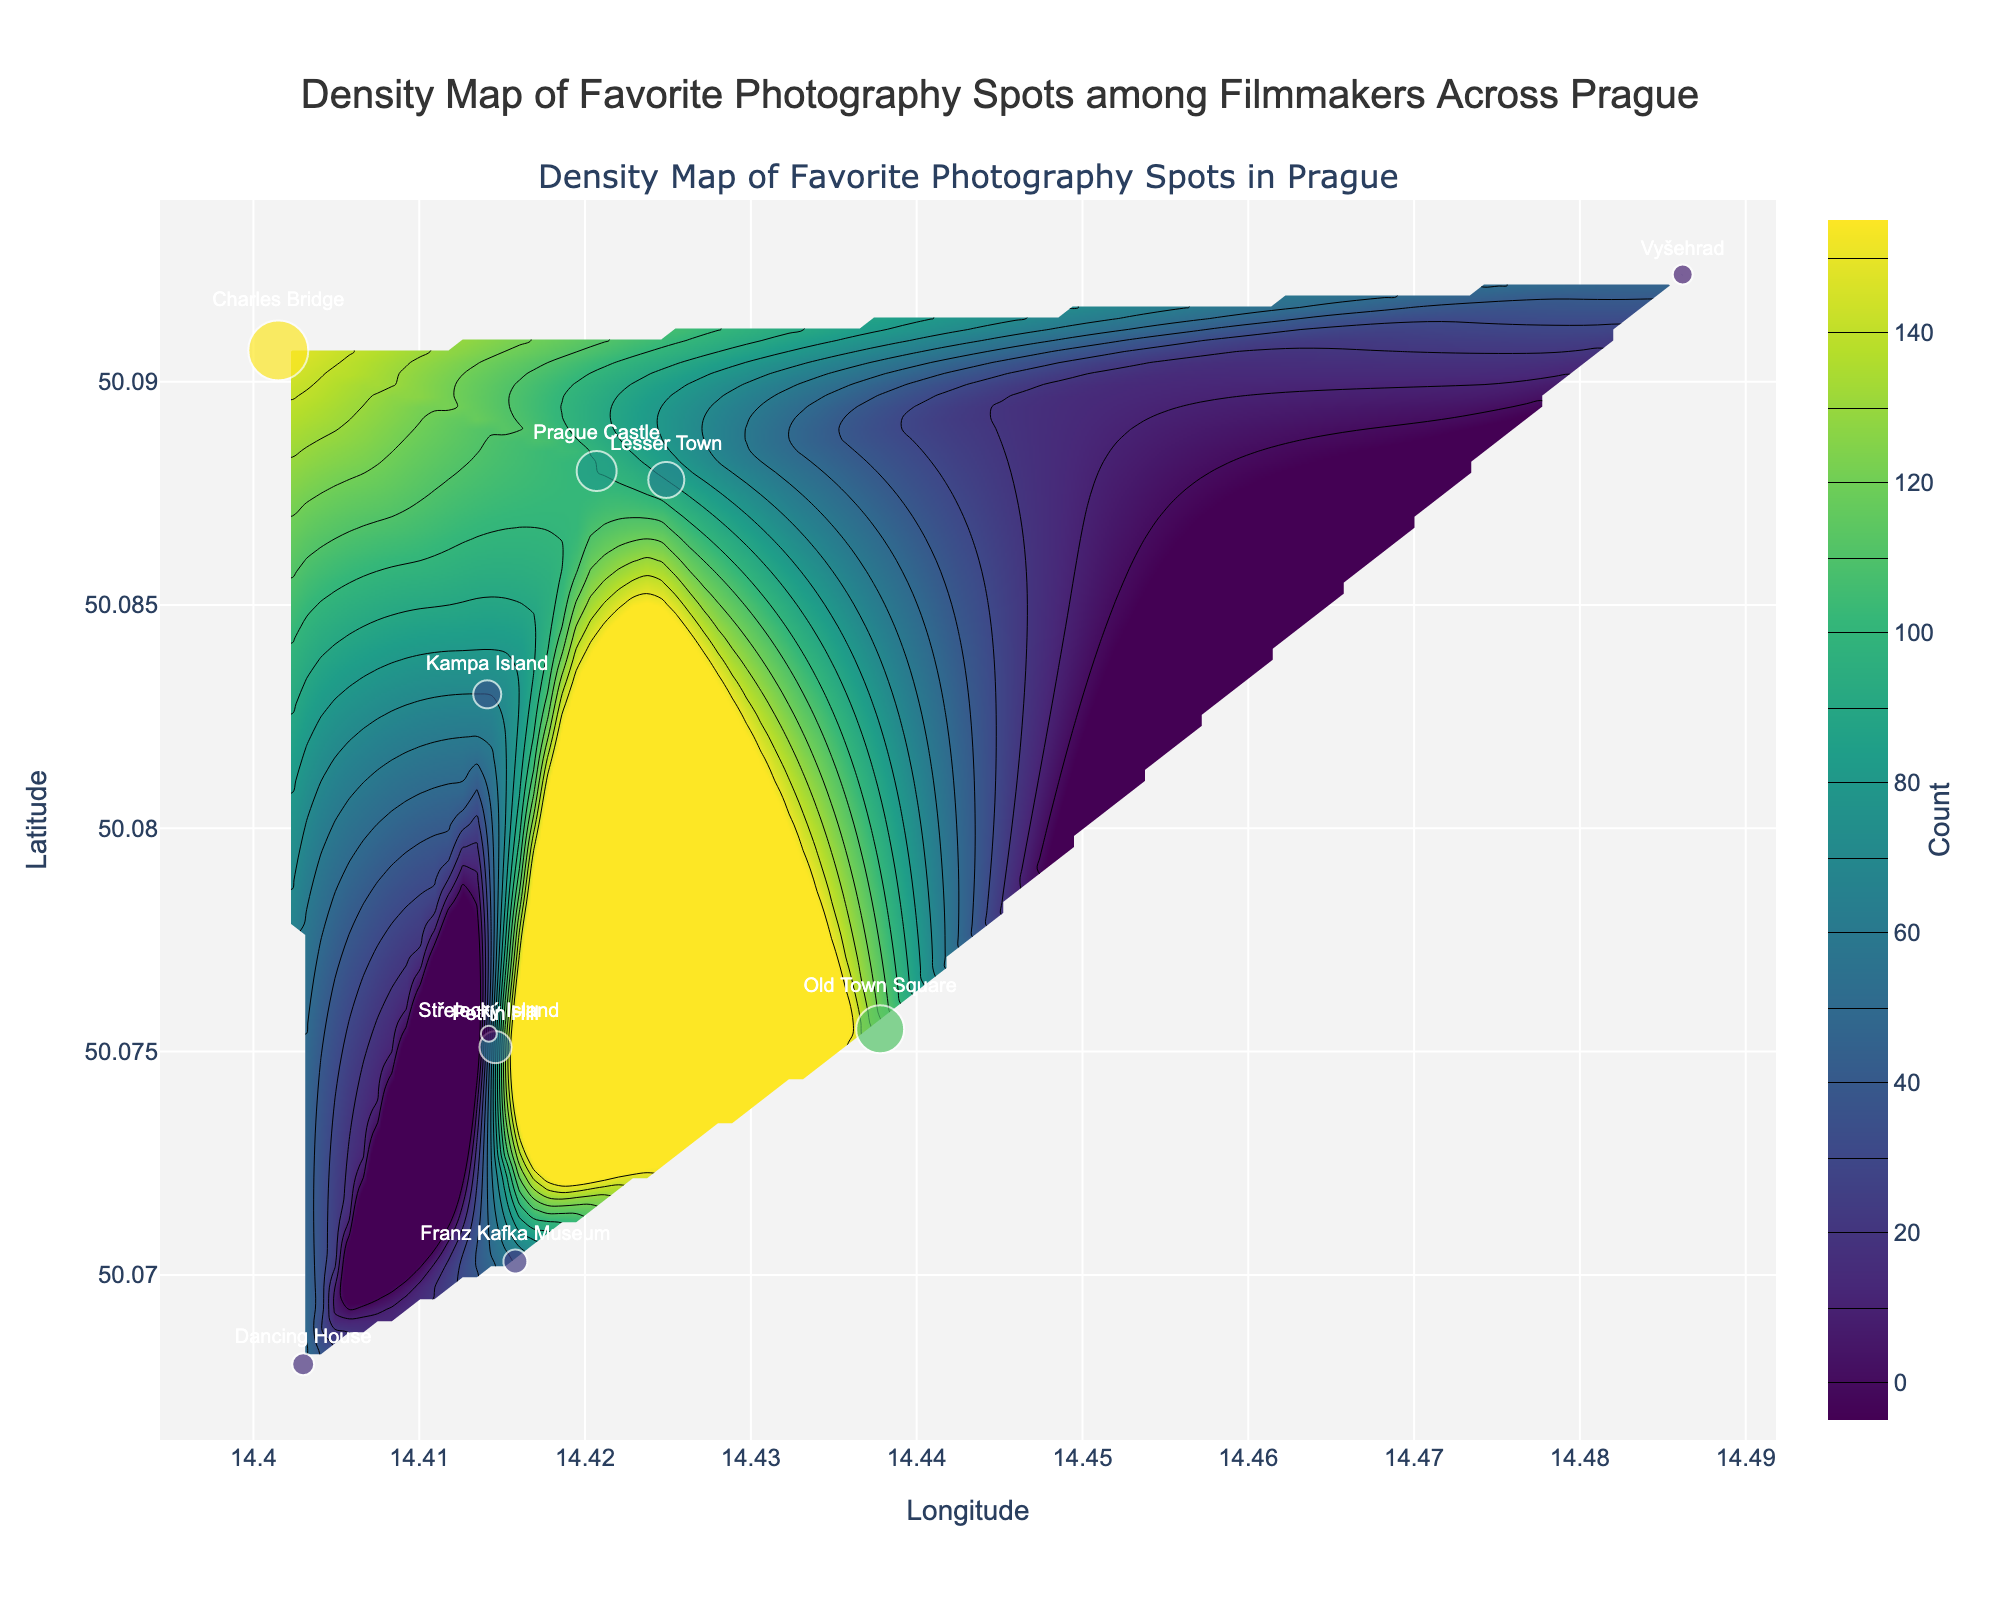What is the title of the figure? The title is displayed at the top center of the figure, which serves as a concise description of what the figure represents.
Answer: Density Map of Favorite Photography Spots among Filmmakers Across Prague How many photography spots are marked on the map? Each spot is represented by a marker on the map. By counting the markers, we can determine the number of spots.
Answer: 10 Which location has the highest count of favorite photography spots? The marker with the largest size and highest color intensity represents the spot with the highest count.
Answer: Charles Bridge What are the longitude and latitude ranges shown in the figure? The longitude and latitude ranges can be determined by looking at the x-axis and y-axis limits respectively.
Answer: Longitude: 14.4015 to 14.4862, Latitude: 50.0680 to 50.0924 Which photography spot has a count of less than 50? Look for the markers with smaller sizes and lower color intensity, and check the text next to the markers for the count value.
Answer: Střelecký Island Compare the counts of Prague Castle and Petřín Hill. Which one is higher? Examine the sizes of the markers and the text next to them for both spots.
Answer: Prague Castle What is the average count of photography spots shown on the map? Sum the counts of all spots and divide by the number of spots. (120 + 150 + 100 + 90 + 70 + 80 + 60 + 50 + 40 + 55) / 10 = 81.5
Answer: 81.5 How many photography spots have a count greater than 100? Look for markers with a size that corresponds to a count greater than 100 and count them.
Answer: 2 (Charles Bridge and Old Town Square) Which area has the highest density of favorite photography spots? The highest density is indicated by the area with the darkest color on the contour plot.
Answer: Charles Bridge and Old Town Square Is Vyšehrad one of the spots with the highest density? Check the marker size and placement on the contour plot to determine if it lies in a high-density area.
Answer: No 